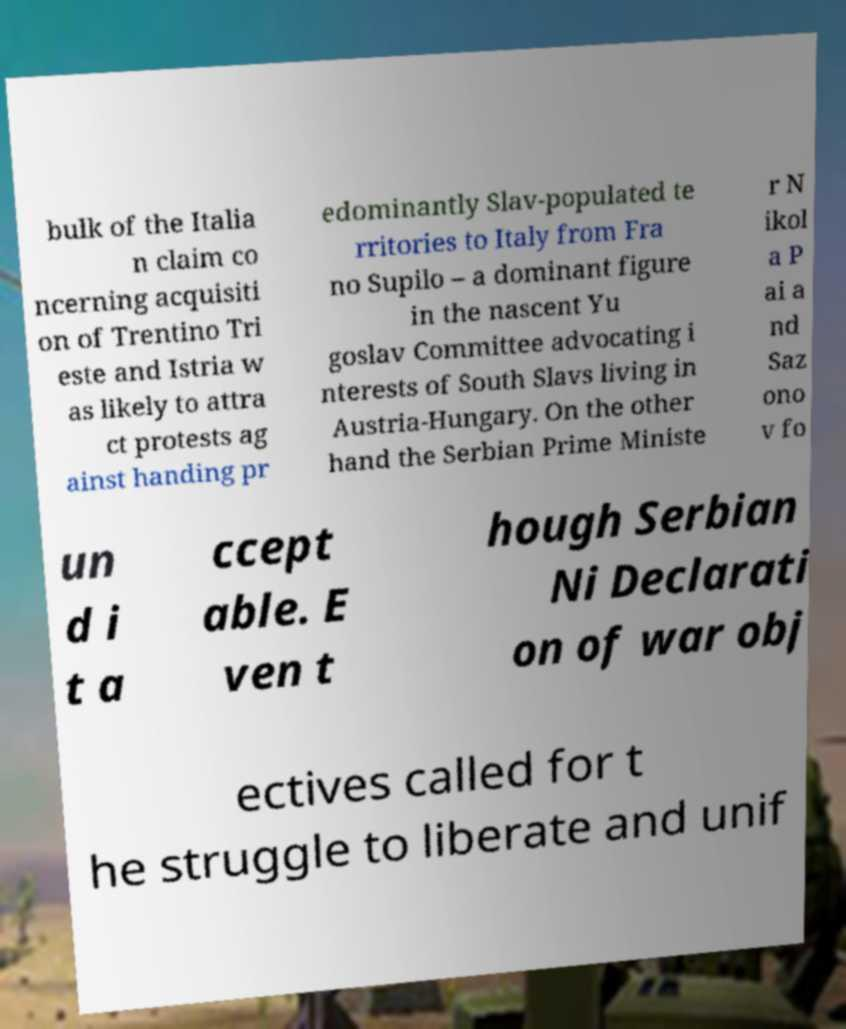Can you read and provide the text displayed in the image?This photo seems to have some interesting text. Can you extract and type it out for me? bulk of the Italia n claim co ncerning acquisiti on of Trentino Tri este and Istria w as likely to attra ct protests ag ainst handing pr edominantly Slav-populated te rritories to Italy from Fra no Supilo – a dominant figure in the nascent Yu goslav Committee advocating i nterests of South Slavs living in Austria-Hungary. On the other hand the Serbian Prime Ministe r N ikol a P ai a nd Saz ono v fo un d i t a ccept able. E ven t hough Serbian Ni Declarati on of war obj ectives called for t he struggle to liberate and unif 